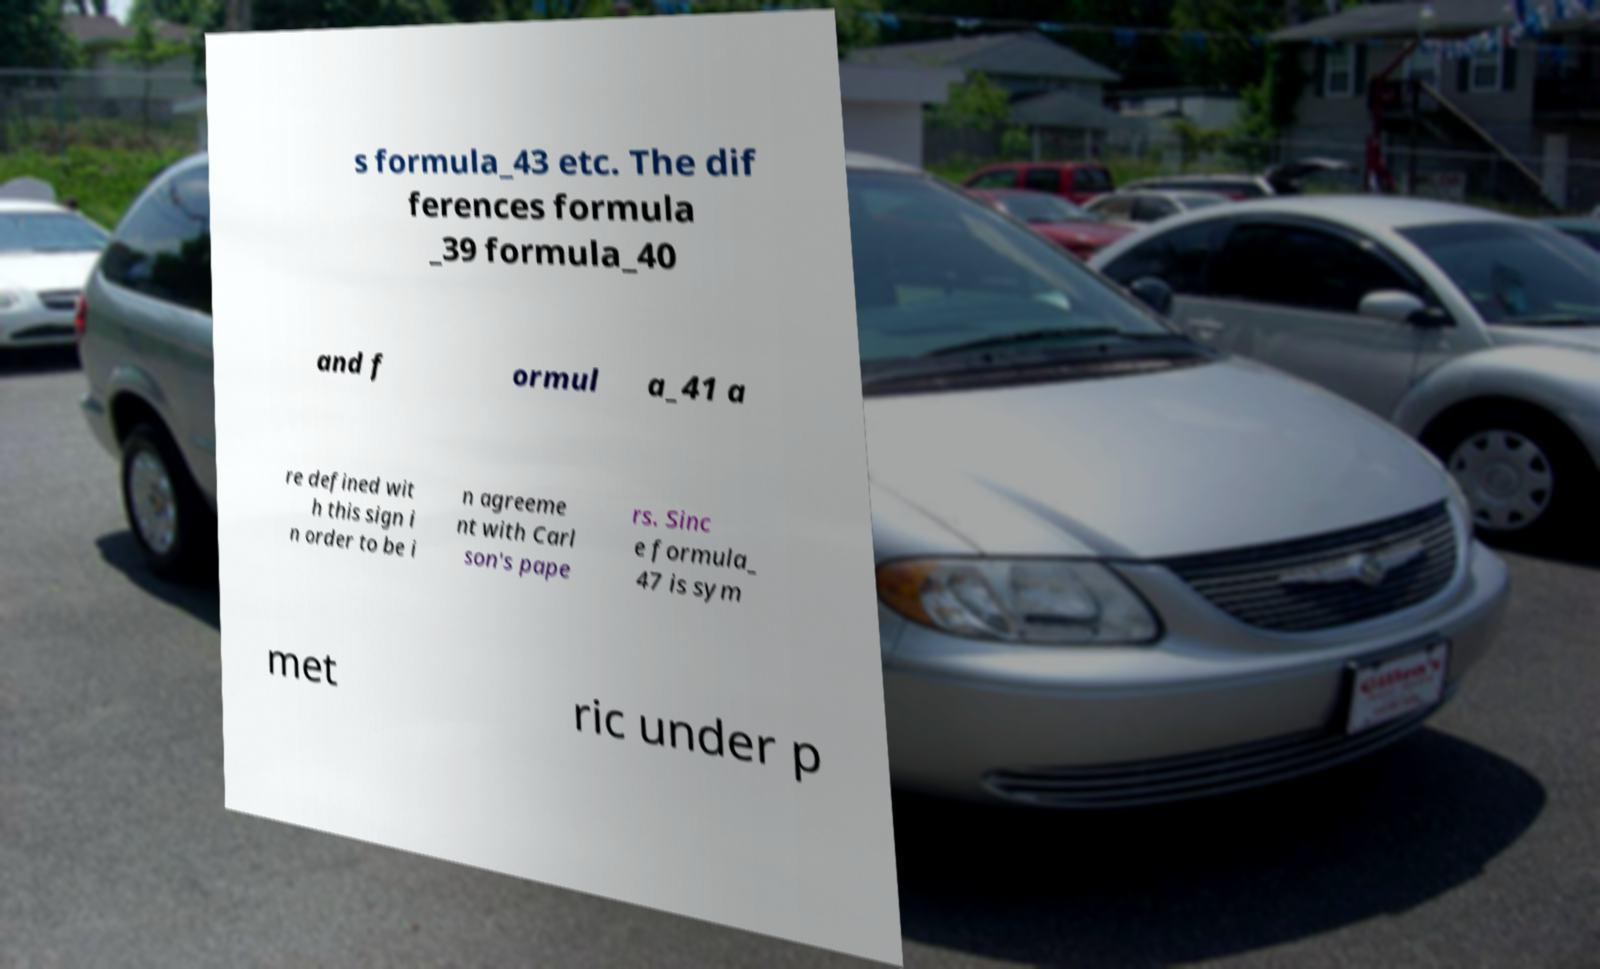For documentation purposes, I need the text within this image transcribed. Could you provide that? s formula_43 etc. The dif ferences formula _39 formula_40 and f ormul a_41 a re defined wit h this sign i n order to be i n agreeme nt with Carl son's pape rs. Sinc e formula_ 47 is sym met ric under p 